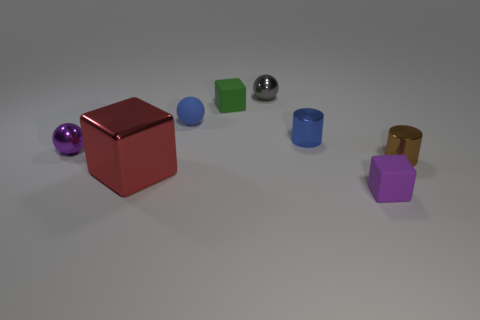Does the tiny cylinder on the left side of the tiny purple matte thing have the same color as the matte object left of the small green cube?
Provide a short and direct response. Yes. There is a rubber ball that is the same size as the green cube; what color is it?
Offer a very short reply. Blue. Are there the same number of green cubes that are behind the gray ball and small purple blocks on the left side of the small purple shiny thing?
Give a very brief answer. Yes. The small cylinder that is in front of the purple thing on the left side of the gray metal thing is made of what material?
Provide a succinct answer. Metal. How many things are either small rubber things or blue objects?
Keep it short and to the point. 4. Are there fewer brown things than purple things?
Provide a short and direct response. Yes. What is the size of the cube that is made of the same material as the small brown object?
Make the answer very short. Large. What size is the red thing?
Provide a short and direct response. Large. What is the shape of the tiny brown metal thing?
Offer a very short reply. Cylinder. Does the small shiny thing that is left of the tiny gray sphere have the same color as the big object?
Offer a terse response. No. 